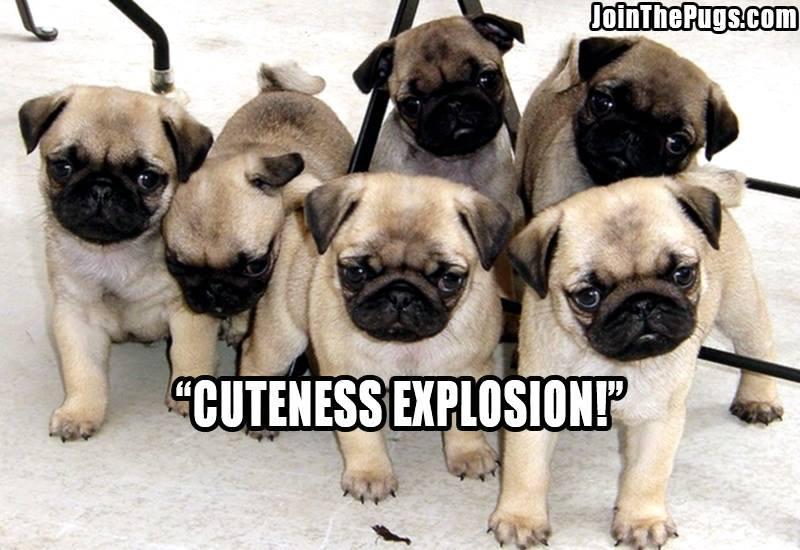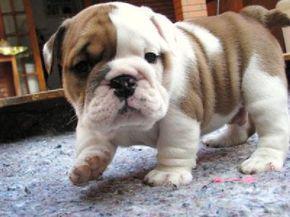The first image is the image on the left, the second image is the image on the right. Examine the images to the left and right. Is the description "There is exactly one dog in every image and at least one dog is looking directly at the camera." accurate? Answer yes or no. No. The first image is the image on the left, the second image is the image on the right. Assess this claim about the two images: "The left image contains exactly one pug dog.". Correct or not? Answer yes or no. No. 